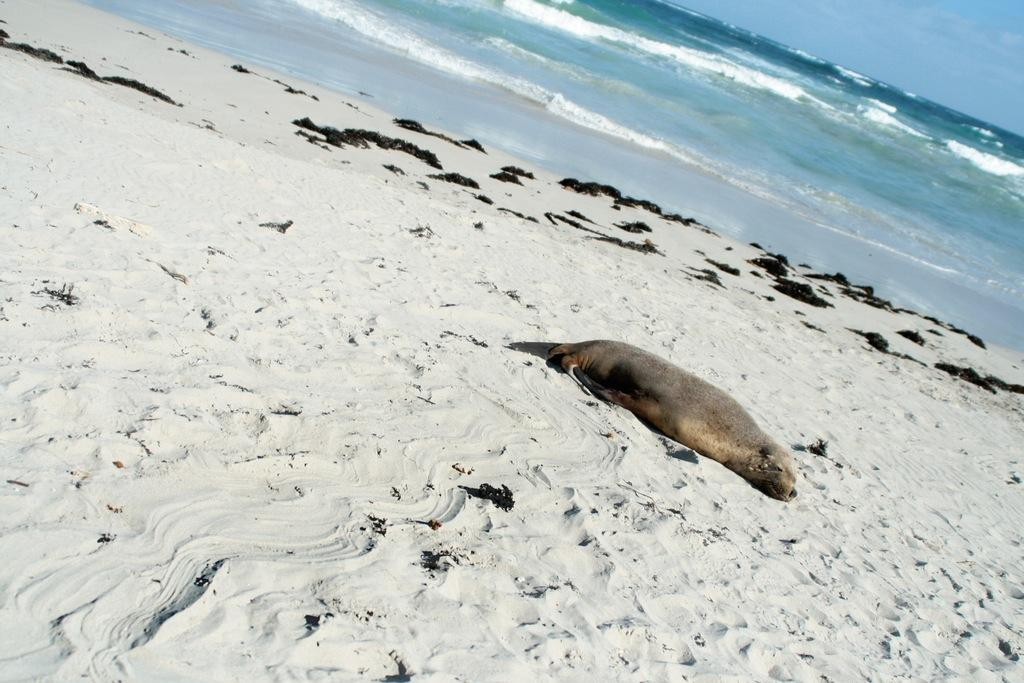What is the animal lying on in the image? The animal is lying on the sand in the image. What natural body of water can be seen in the image? The sea is visible in the image. What part of the sky is visible in the image? The sky is visible in the image. What type of weather condition can be inferred from the image? Clouds are present in the sky, suggesting a partly cloudy day. What type of tin can be seen in the animal's bag in the image? There is no tin or bag present in the image; it only features an animal lying on the sand, the sea, and the sky with clouds. 